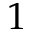Convert formula to latex. <formula><loc_0><loc_0><loc_500><loc_500>1</formula> 